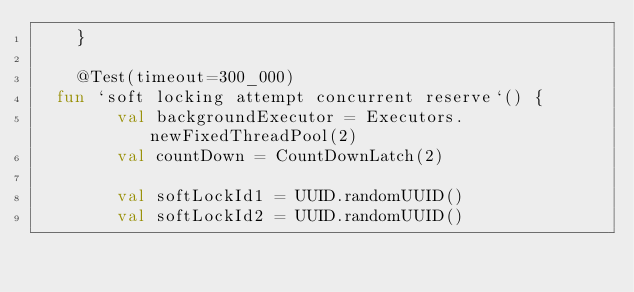Convert code to text. <code><loc_0><loc_0><loc_500><loc_500><_Kotlin_>    }

    @Test(timeout=300_000)
	fun `soft locking attempt concurrent reserve`() {
        val backgroundExecutor = Executors.newFixedThreadPool(2)
        val countDown = CountDownLatch(2)

        val softLockId1 = UUID.randomUUID()
        val softLockId2 = UUID.randomUUID()
</code> 